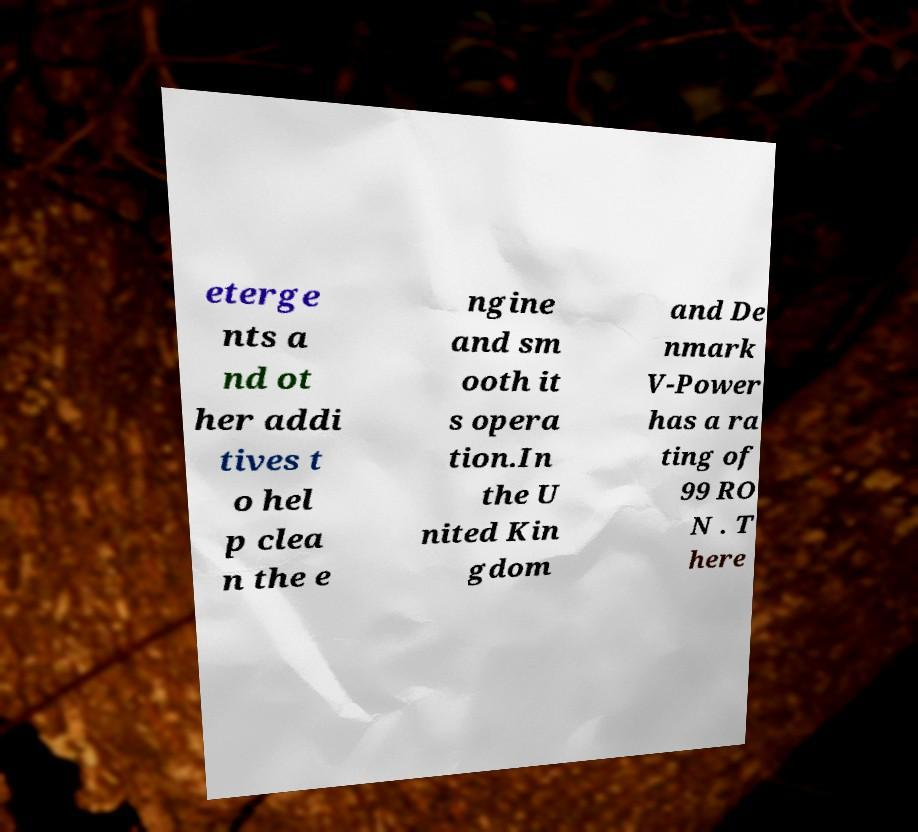Please identify and transcribe the text found in this image. eterge nts a nd ot her addi tives t o hel p clea n the e ngine and sm ooth it s opera tion.In the U nited Kin gdom and De nmark V-Power has a ra ting of 99 RO N . T here 